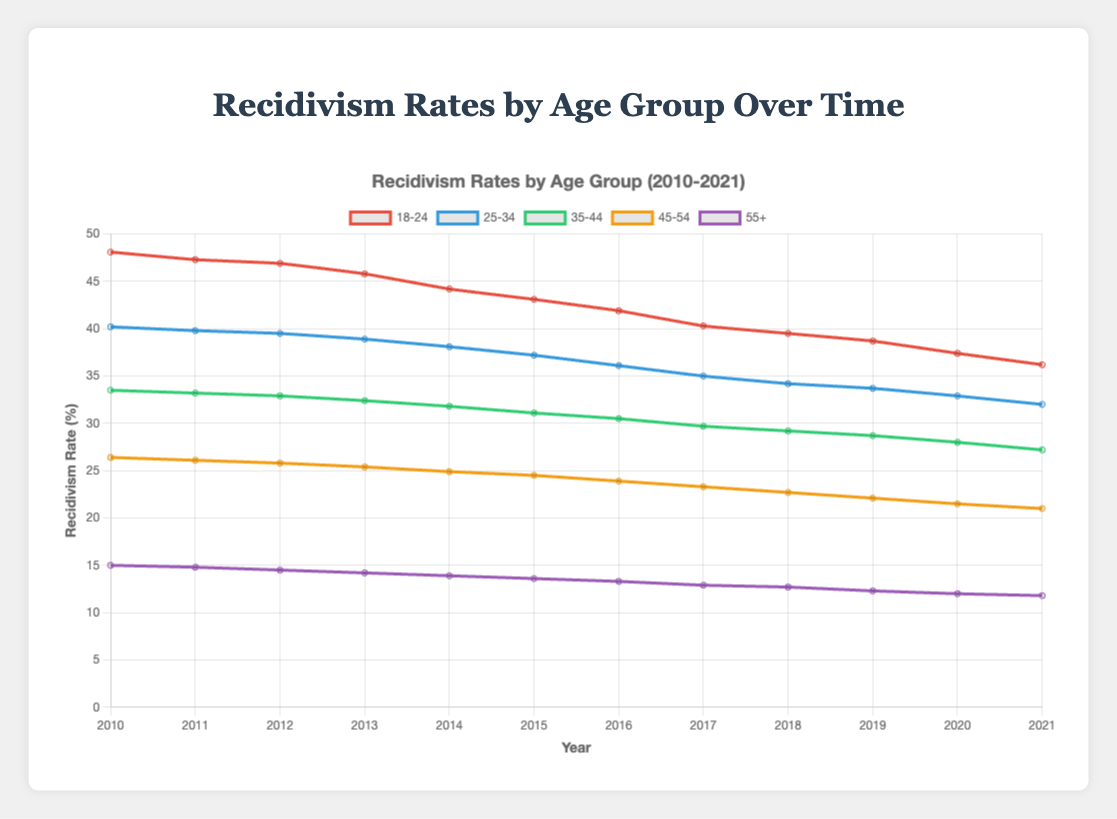What age group had the highest recidivism rate in 2010? To answer this, examine the values for the year 2010. The highest value is in the "18-24" age group with a recidivism rate of 48.1%.
Answer: 18-24 How did the recidivism rate for the "25-34" age group change from 2010 to 2021? Look at the values for the "25-34" age group in 2010 and 2021. In 2010, it was 40.2%, and in 2021, it was 32.0%. The decrease is calculated as 40.2% - 32.0%, which is 8.2%.
Answer: Decreased by 8.2% Which age group had the smallest decrease in recidivism rates from 2010 to 2021? Calculate the decrease for each age group from 2010 to 2021: 18-24 is 48.1% - 36.2% = 11.9%; 25-34 is 40.2% - 32.0% = 8.2%; 35-44 is 33.5% - 27.2% = 6.3%; 45-54 is 26.4% - 21.0% = 5.4%; 55+ is 15.0% - 11.8% = 3.2%. The smallest decrease is in the "55+" age group.
Answer: 55+ Which age group consistently had the lowest recidivism rate over the years? Observe each line on the chart and identify the one that remains the lowest across all years. The "55+" age group consistently has the lowest recidivism rates.
Answer: 55+ What is the average recidivism rate for the "35-44" age group over the years 2010 to 2021? Add the recidivism rates for the "35-44" age group from 2010 to 2021 and divide by the number of years: (33.5 + 33.2 + 32.9 + 32.4 + 31.8 + 31.1 + 30.5 + 29.7 + 29.2 + 28.7 + 28.0 + 27.2) / 12 = 30.8%.
Answer: 30.8% Between which two consecutive years did the "18-24" age group see the greatest decrease in recidivism rate? Calculate the year-to-year differences for the "18-24" age group: (48.1 - 47.3), (47.3 - 46.9), (46.9 - 45.8), (45.8 - 44.2), (44.2 - 43.1), (43.1 - 41.9), (41.9 - 40.3), (40.3 - 39.5), (39.5 - 38.7), (38.7 - 37.4), (37.4 - 36.2). The greatest decrease was from 2013 to 2014: 46.9 - 45.8 = 1.1%.
Answer: 2013 to 2014 Which age group showed the most significant overall trend (either increase or decrease) in recidivism rates from 2010 to 2021? Compare the differences from 2010 to 2021 for all age groups: 18-24 (11.9%), 25-34 (8.2%), 35-44 (6.3%), 45-54 (5.4%), 55+ (3.2%). The "18-24" group shows the most significant decrease.
Answer: 18-24 